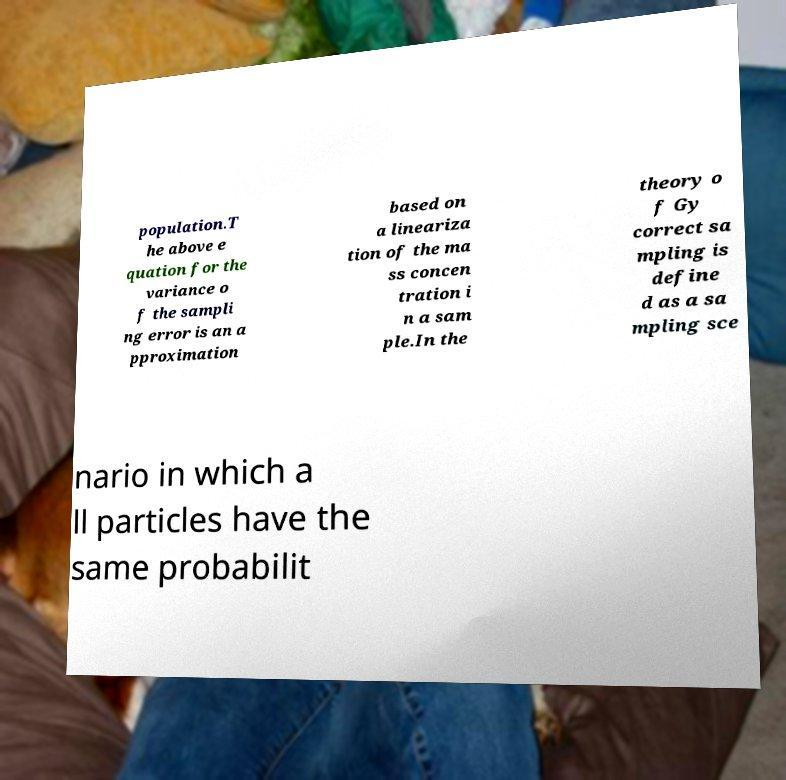Please identify and transcribe the text found in this image. population.T he above e quation for the variance o f the sampli ng error is an a pproximation based on a lineariza tion of the ma ss concen tration i n a sam ple.In the theory o f Gy correct sa mpling is define d as a sa mpling sce nario in which a ll particles have the same probabilit 